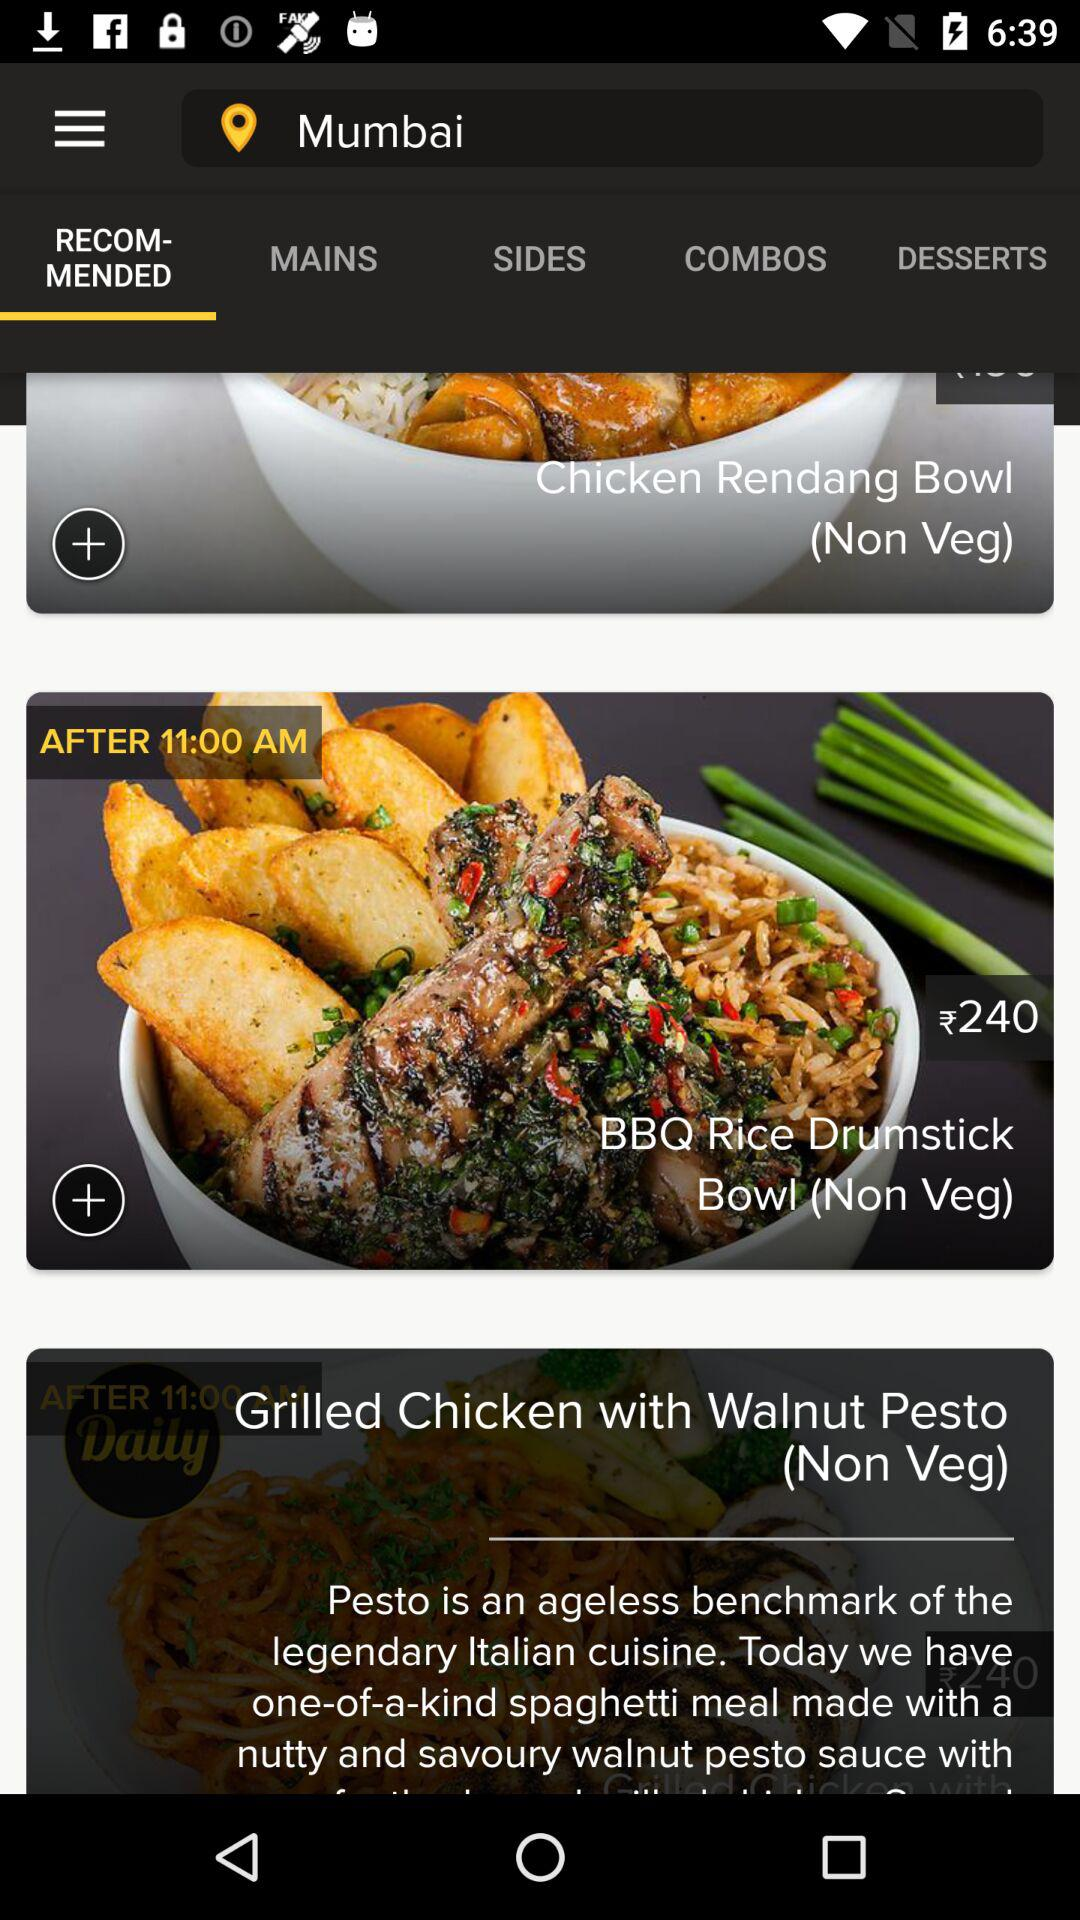What is the price of the "BBQ Rice Drumstick"? The price is ₹240. 